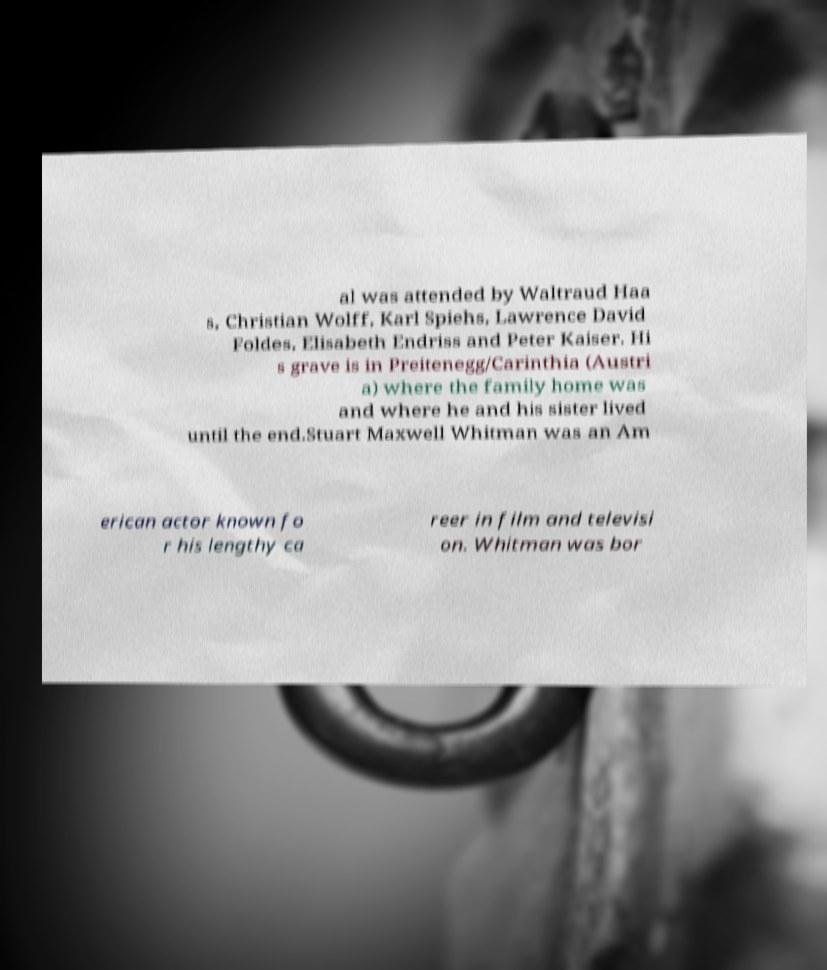Please identify and transcribe the text found in this image. al was attended by Waltraud Haa s, Christian Wolff, Karl Spiehs, Lawrence David Foldes, Elisabeth Endriss and Peter Kaiser. Hi s grave is in Preitenegg/Carinthia (Austri a) where the family home was and where he and his sister lived until the end.Stuart Maxwell Whitman was an Am erican actor known fo r his lengthy ca reer in film and televisi on. Whitman was bor 